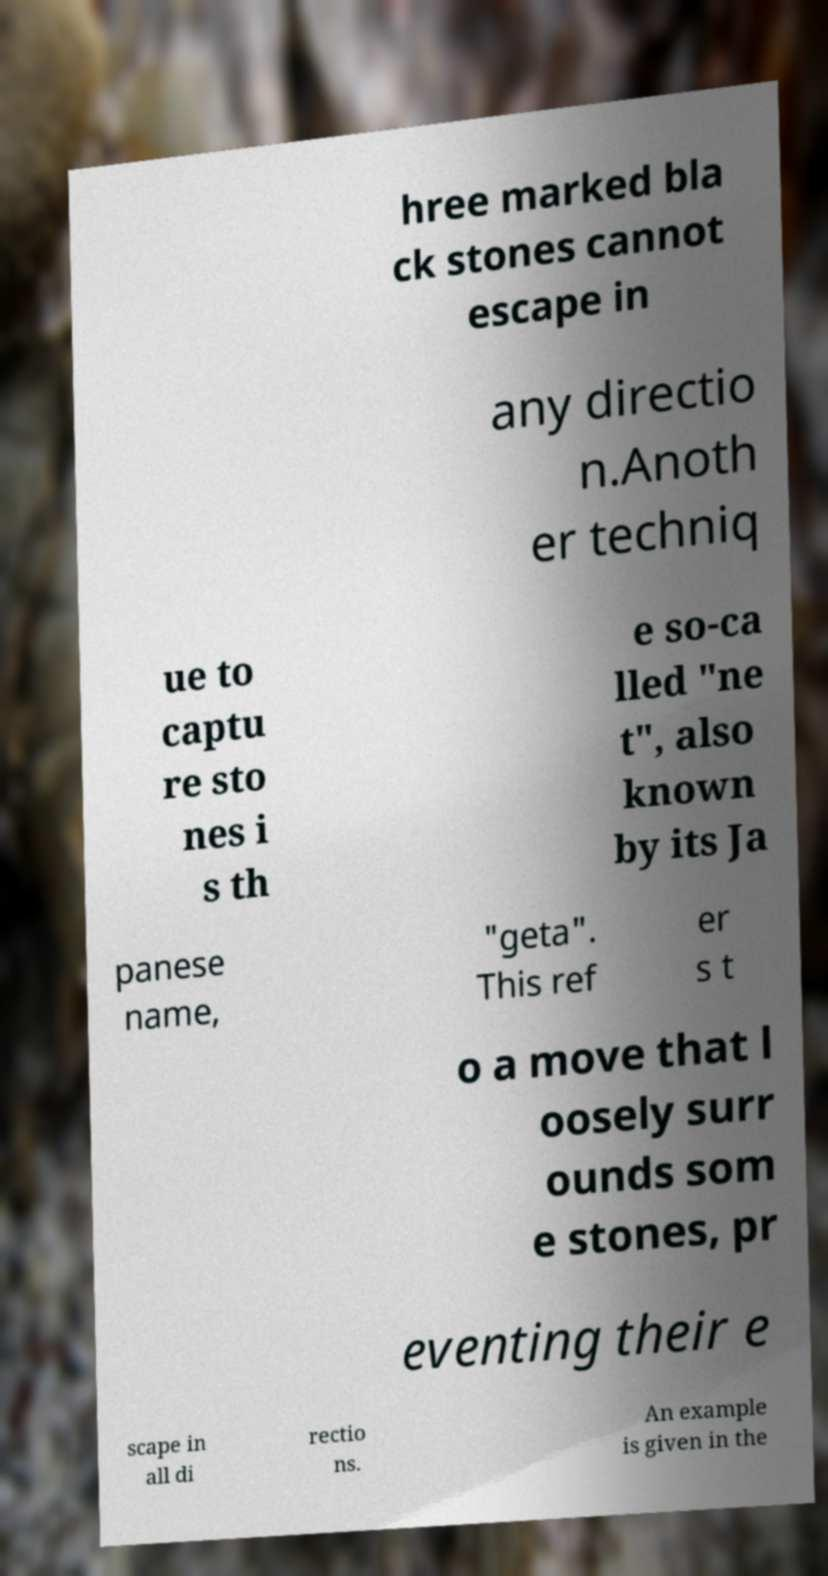What messages or text are displayed in this image? I need them in a readable, typed format. hree marked bla ck stones cannot escape in any directio n.Anoth er techniq ue to captu re sto nes i s th e so-ca lled "ne t", also known by its Ja panese name, "geta". This ref er s t o a move that l oosely surr ounds som e stones, pr eventing their e scape in all di rectio ns. An example is given in the 